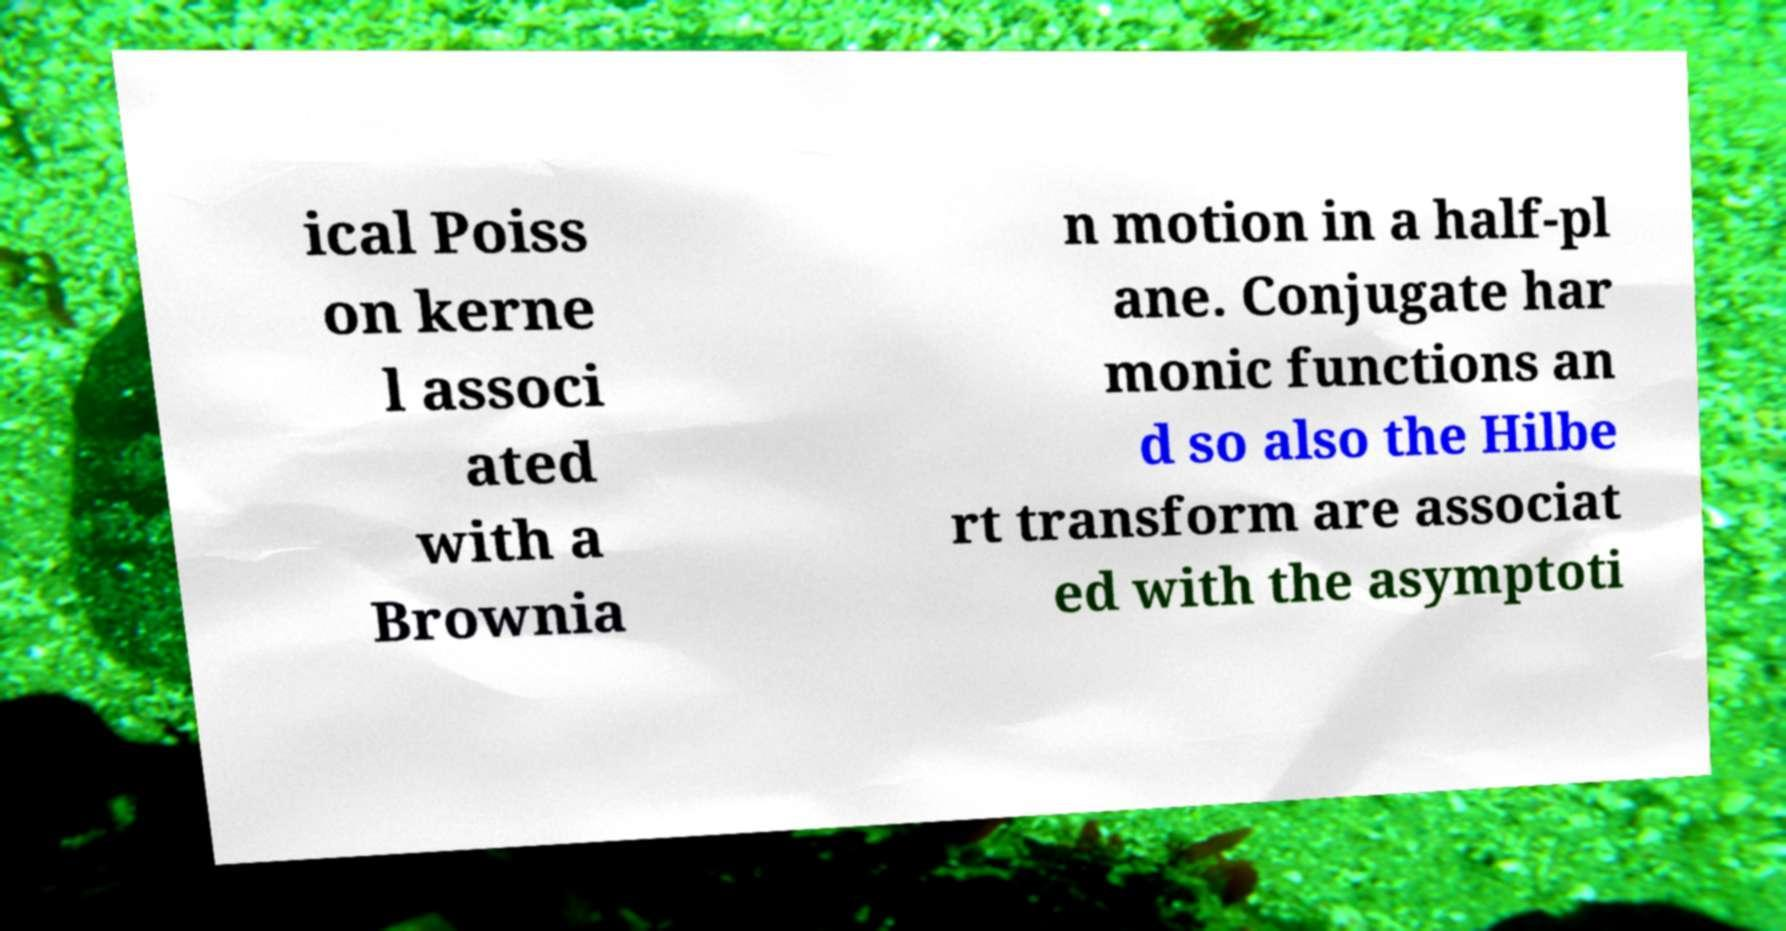Could you extract and type out the text from this image? ical Poiss on kerne l associ ated with a Brownia n motion in a half-pl ane. Conjugate har monic functions an d so also the Hilbe rt transform are associat ed with the asymptoti 